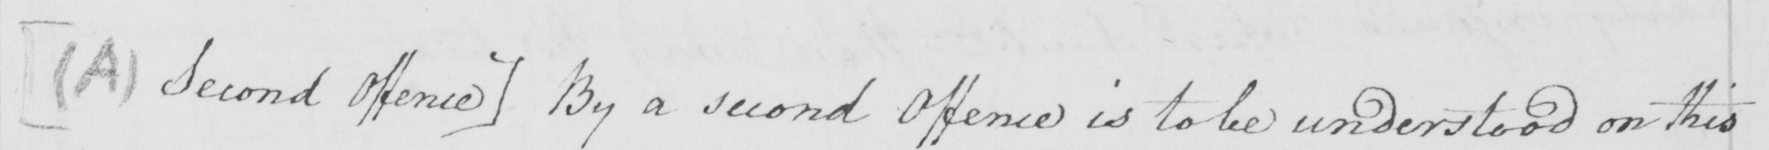What text is written in this handwritten line? [  ( A )  Second Offence ]  By a second Offence is to be understood on this 